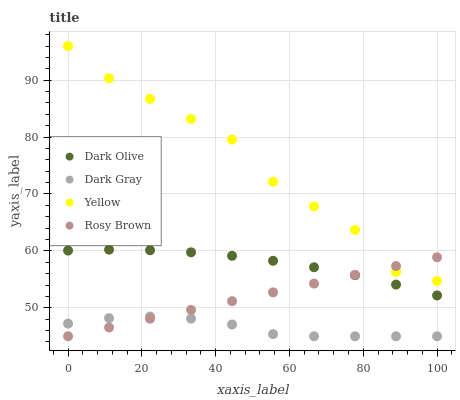Does Dark Gray have the minimum area under the curve?
Answer yes or no. Yes. Does Yellow have the maximum area under the curve?
Answer yes or no. Yes. Does Rosy Brown have the minimum area under the curve?
Answer yes or no. No. Does Rosy Brown have the maximum area under the curve?
Answer yes or no. No. Is Rosy Brown the smoothest?
Answer yes or no. Yes. Is Yellow the roughest?
Answer yes or no. Yes. Is Dark Olive the smoothest?
Answer yes or no. No. Is Dark Olive the roughest?
Answer yes or no. No. Does Dark Gray have the lowest value?
Answer yes or no. Yes. Does Dark Olive have the lowest value?
Answer yes or no. No. Does Yellow have the highest value?
Answer yes or no. Yes. Does Rosy Brown have the highest value?
Answer yes or no. No. Is Dark Olive less than Yellow?
Answer yes or no. Yes. Is Yellow greater than Dark Olive?
Answer yes or no. Yes. Does Rosy Brown intersect Dark Olive?
Answer yes or no. Yes. Is Rosy Brown less than Dark Olive?
Answer yes or no. No. Is Rosy Brown greater than Dark Olive?
Answer yes or no. No. Does Dark Olive intersect Yellow?
Answer yes or no. No. 